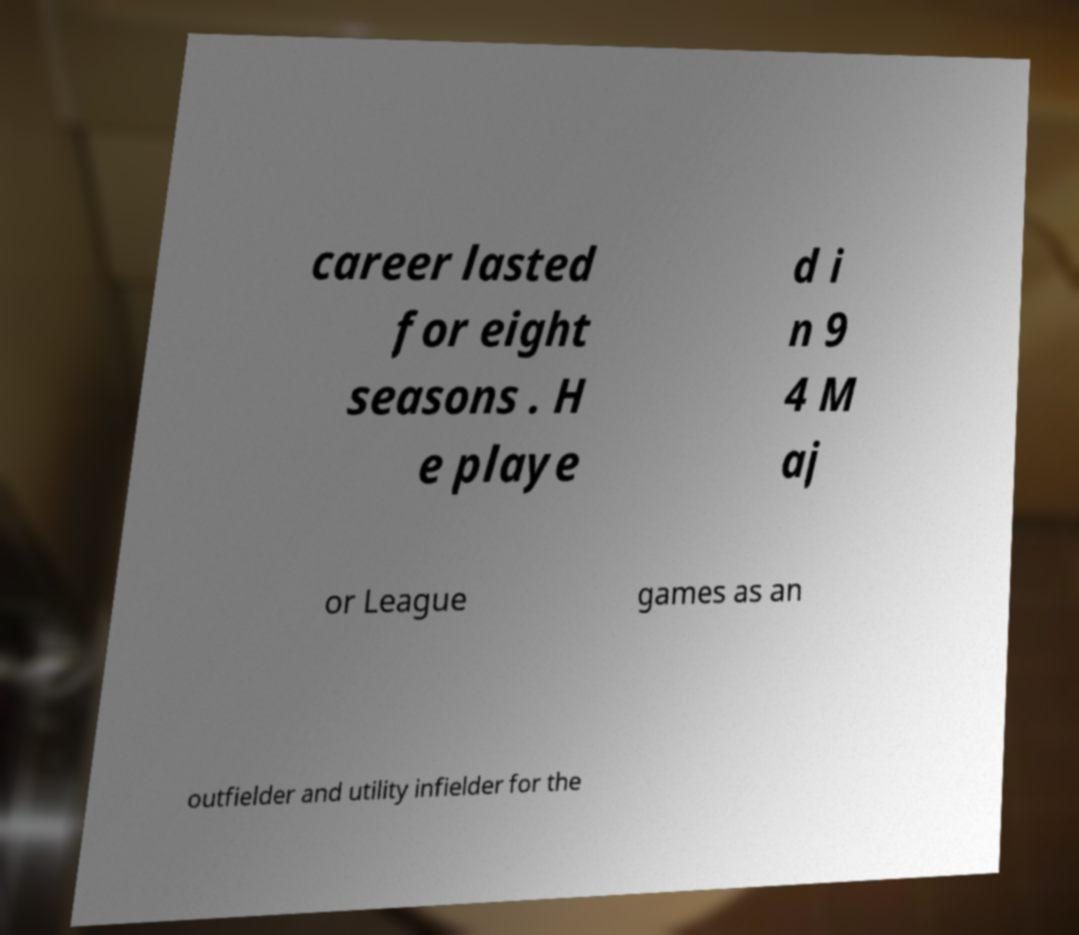Can you read and provide the text displayed in the image?This photo seems to have some interesting text. Can you extract and type it out for me? career lasted for eight seasons . H e playe d i n 9 4 M aj or League games as an outfielder and utility infielder for the 